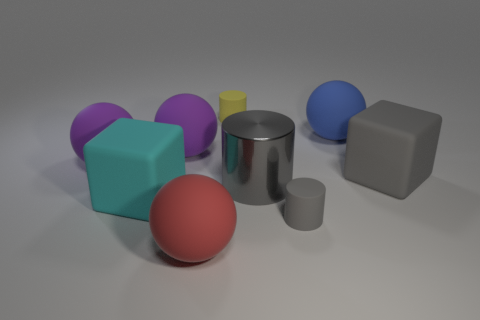How many gray cylinders must be subtracted to get 1 gray cylinders? 1 Subtract all blue spheres. How many spheres are left? 3 Subtract all yellow cylinders. How many cylinders are left? 2 Subtract 2 cubes. How many cubes are left? 0 Add 1 tiny brown rubber cubes. How many objects exist? 10 Subtract all blocks. How many objects are left? 7 Subtract all green cylinders. Subtract all brown balls. How many cylinders are left? 3 Subtract all yellow cylinders. How many red spheres are left? 1 Subtract all rubber balls. Subtract all metal cylinders. How many objects are left? 4 Add 6 purple things. How many purple things are left? 8 